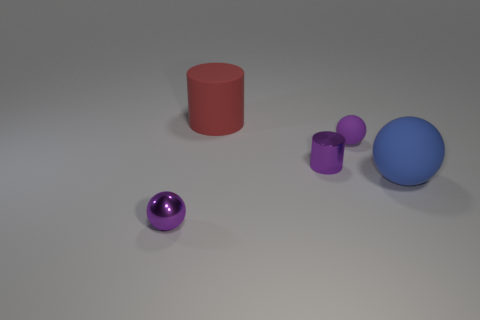There is another small sphere that is the same color as the small rubber ball; what material is it?
Your answer should be very brief. Metal. There is a cylinder on the right side of the red cylinder; does it have the same color as the tiny sphere that is to the left of the tiny shiny cylinder?
Offer a terse response. Yes. Are there any large brown blocks that have the same material as the blue thing?
Your answer should be very brief. No. There is a metal object to the left of the small shiny object right of the red cylinder; what size is it?
Keep it short and to the point. Small. Are there more small shiny objects than blue matte things?
Your response must be concise. Yes. Do the purple object that is left of the red matte cylinder and the red thing have the same size?
Keep it short and to the point. No. What number of small shiny cylinders have the same color as the metallic sphere?
Ensure brevity in your answer.  1. Does the purple rubber thing have the same shape as the big blue object?
Make the answer very short. Yes. There is a blue matte thing that is the same shape as the purple matte object; what is its size?
Provide a short and direct response. Large. Is the number of small purple cylinders right of the large rubber cylinder greater than the number of big red things that are on the right side of the blue rubber sphere?
Provide a succinct answer. Yes. 